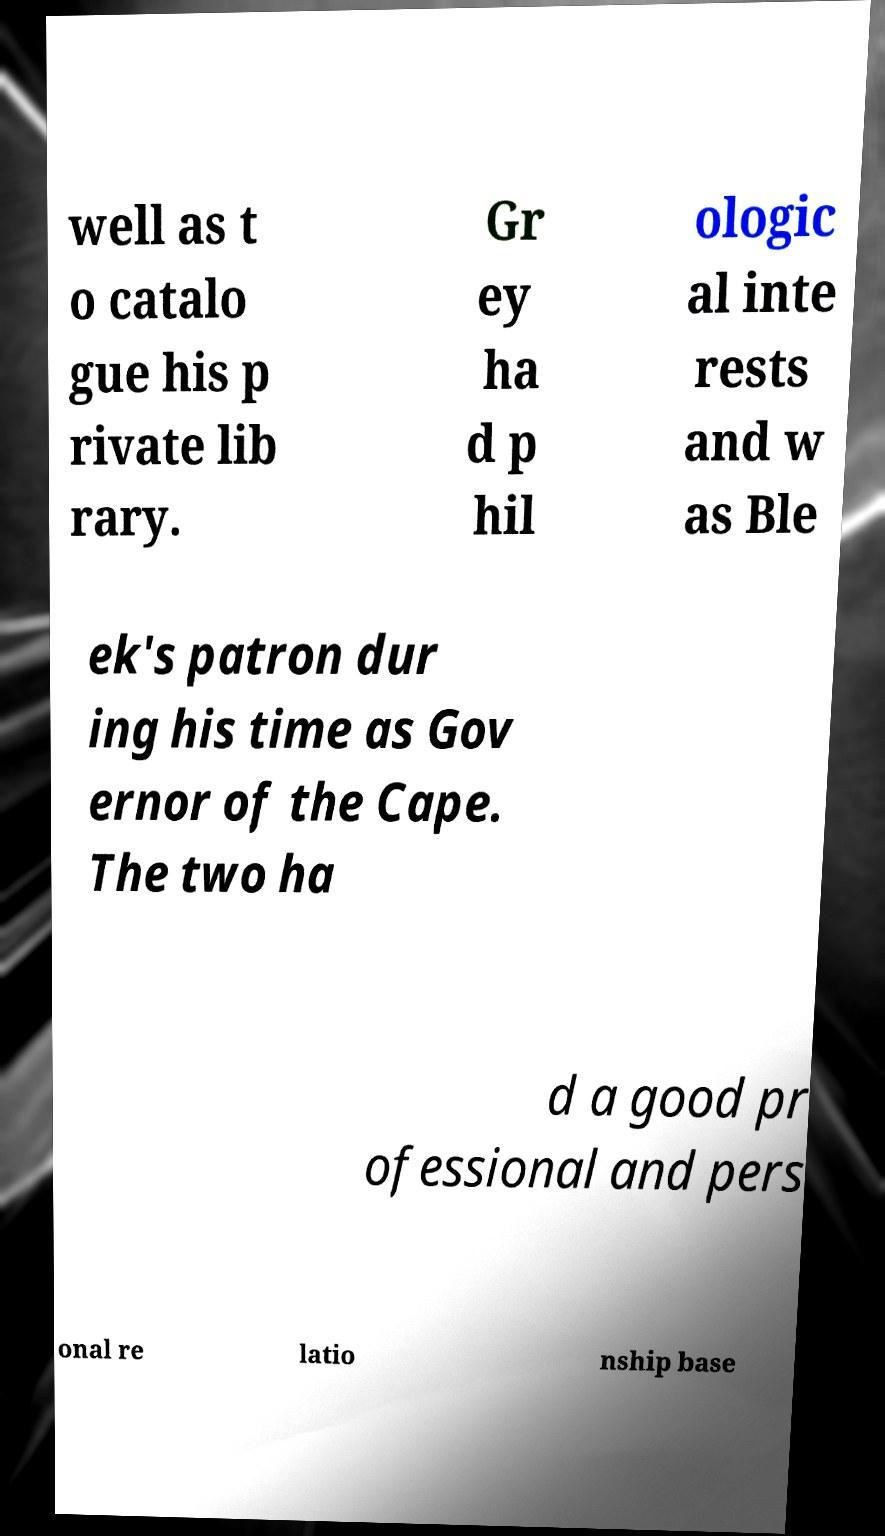Can you read and provide the text displayed in the image?This photo seems to have some interesting text. Can you extract and type it out for me? well as t o catalo gue his p rivate lib rary. Gr ey ha d p hil ologic al inte rests and w as Ble ek's patron dur ing his time as Gov ernor of the Cape. The two ha d a good pr ofessional and pers onal re latio nship base 